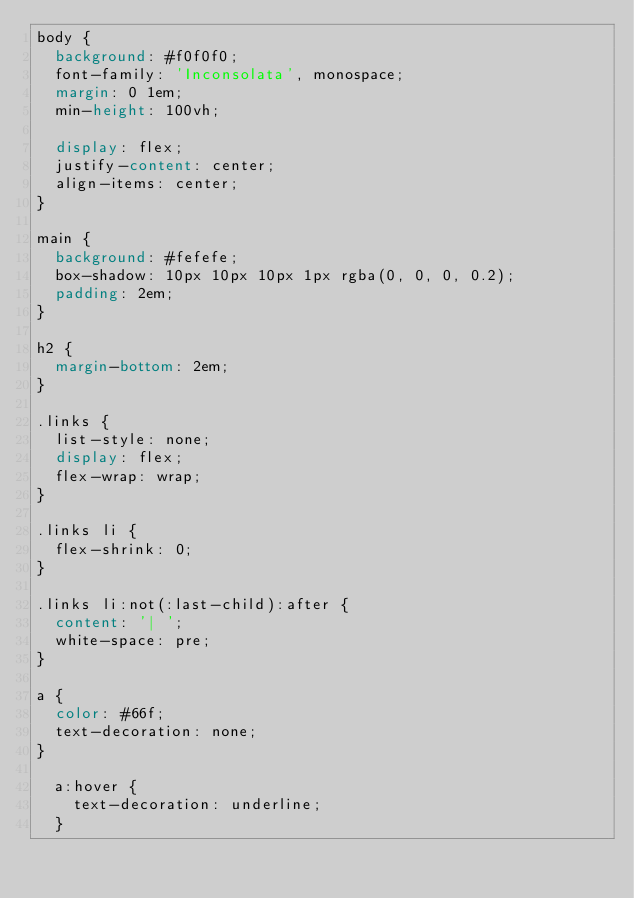<code> <loc_0><loc_0><loc_500><loc_500><_CSS_>body {
  background: #f0f0f0;
  font-family: 'Inconsolata', monospace;
  margin: 0 1em;
  min-height: 100vh;

  display: flex;
  justify-content: center;
  align-items: center;
}

main {
  background: #fefefe;
  box-shadow: 10px 10px 10px 1px rgba(0, 0, 0, 0.2);
  padding: 2em;
}

h2 {
  margin-bottom: 2em;
}

.links {
  list-style: none;
  display: flex;
  flex-wrap: wrap;
}

.links li {
  flex-shrink: 0;
}

.links li:not(:last-child):after {
  content: '| ';
  white-space: pre;
}

a {
  color: #66f;
  text-decoration: none;
}

  a:hover {
    text-decoration: underline;
  }
</code> 